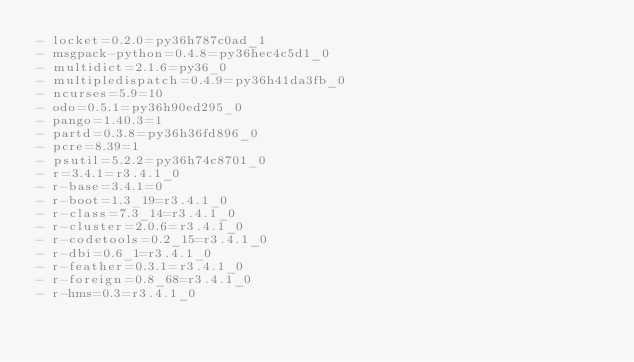Convert code to text. <code><loc_0><loc_0><loc_500><loc_500><_YAML_>- locket=0.2.0=py36h787c0ad_1
- msgpack-python=0.4.8=py36hec4c5d1_0
- multidict=2.1.6=py36_0
- multipledispatch=0.4.9=py36h41da3fb_0
- ncurses=5.9=10
- odo=0.5.1=py36h90ed295_0
- pango=1.40.3=1
- partd=0.3.8=py36h36fd896_0
- pcre=8.39=1
- psutil=5.2.2=py36h74c8701_0
- r=3.4.1=r3.4.1_0
- r-base=3.4.1=0
- r-boot=1.3_19=r3.4.1_0
- r-class=7.3_14=r3.4.1_0
- r-cluster=2.0.6=r3.4.1_0
- r-codetools=0.2_15=r3.4.1_0
- r-dbi=0.6_1=r3.4.1_0
- r-feather=0.3.1=r3.4.1_0
- r-foreign=0.8_68=r3.4.1_0
- r-hms=0.3=r3.4.1_0</code> 